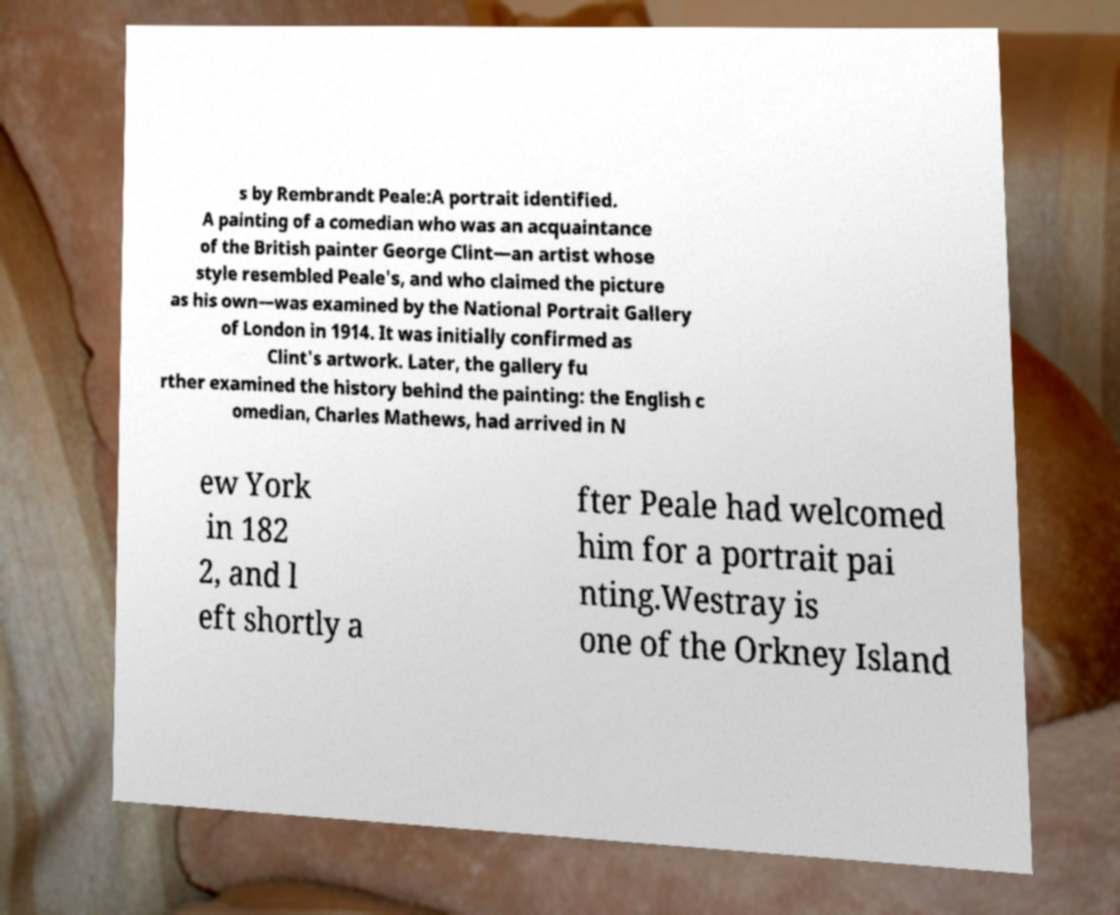Could you extract and type out the text from this image? s by Rembrandt Peale:A portrait identified. A painting of a comedian who was an acquaintance of the British painter George Clint—an artist whose style resembled Peale's, and who claimed the picture as his own—was examined by the National Portrait Gallery of London in 1914. It was initially confirmed as Clint's artwork. Later, the gallery fu rther examined the history behind the painting: the English c omedian, Charles Mathews, had arrived in N ew York in 182 2, and l eft shortly a fter Peale had welcomed him for a portrait pai nting.Westray is one of the Orkney Island 